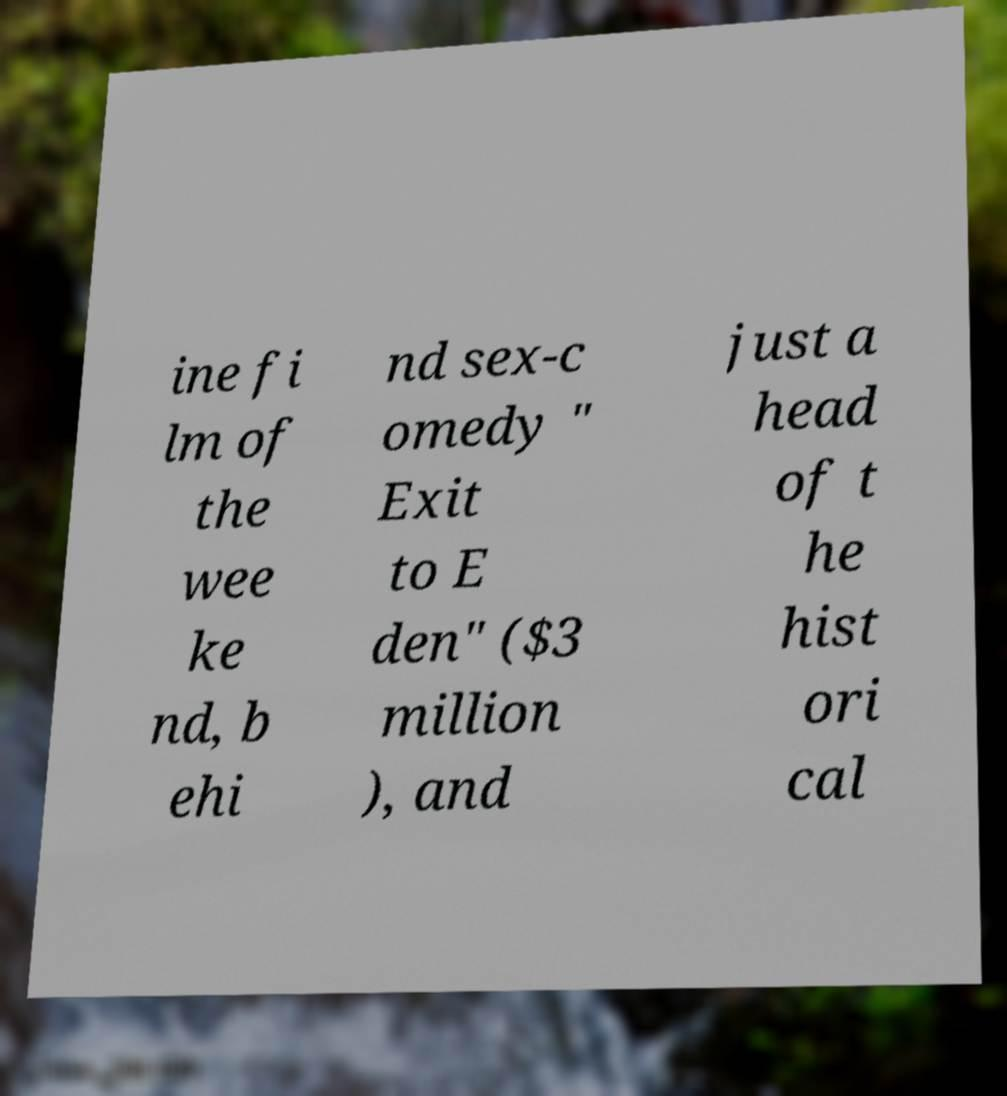I need the written content from this picture converted into text. Can you do that? ine fi lm of the wee ke nd, b ehi nd sex-c omedy " Exit to E den" ($3 million ), and just a head of t he hist ori cal 